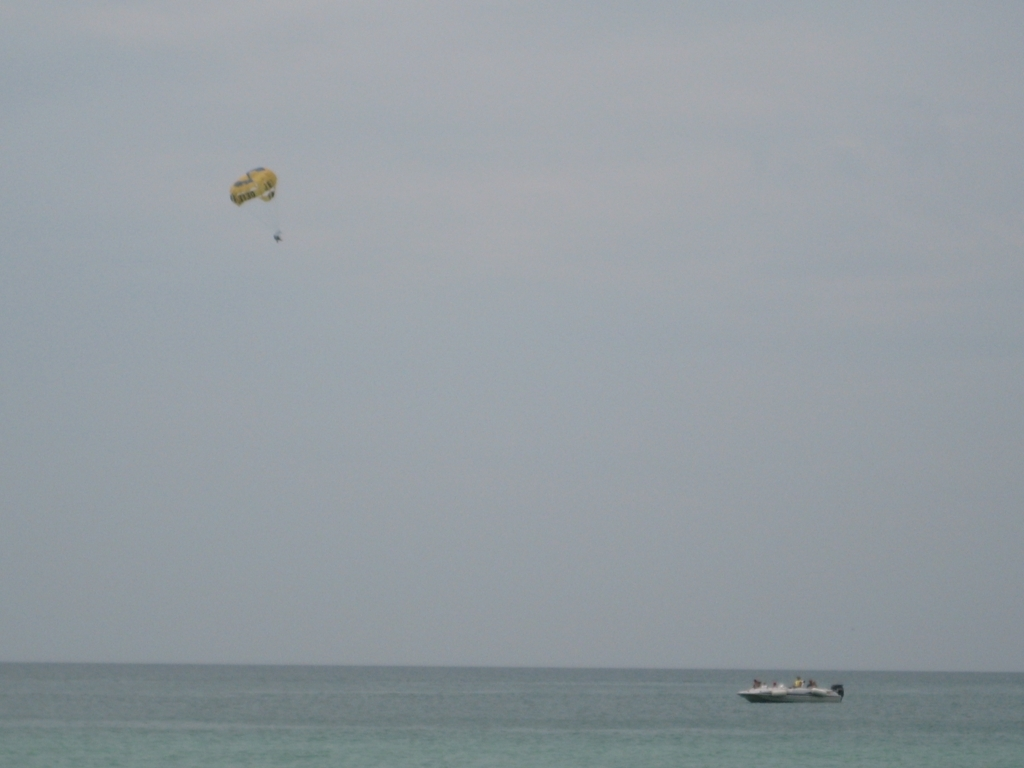What could be improved to enhance the visual appeal of this image? To enhance the visual appeal, this image could be improved in several ways. Increasing contrast and saturation might help to bring out the colors of the sea and sky more vividly. Adjusting the composition, possibly by zooming in or repositioning the angle of the shot to focus more on the parasailer and the boat could create a more engaging scene. Additionally, capturing the image at a time of day when the lighting is more dynamic, such as during golden hour, could add warmth and depth to the picture. 